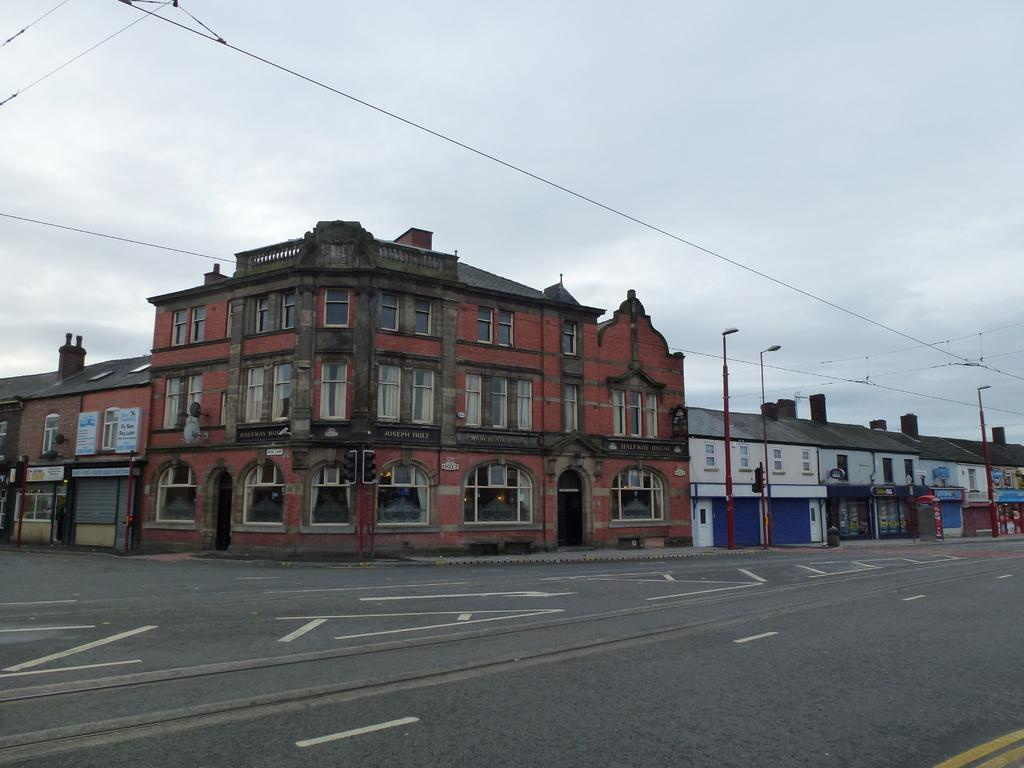What is the main feature of the image? There is a road in the image. What else can be seen along the road? There are poles, boards, and wires in the image. Are there any structures visible in the image? Yes, there are buildings in the image. What can be seen in the background of the image? The sky is visible in the background of the image, and there are clouds in the sky. Can you tell me how many cubs are playing near the buildings in the image? There are no cubs present in the image; it only features a road, poles, boards, wires, buildings, and a sky with clouds. 